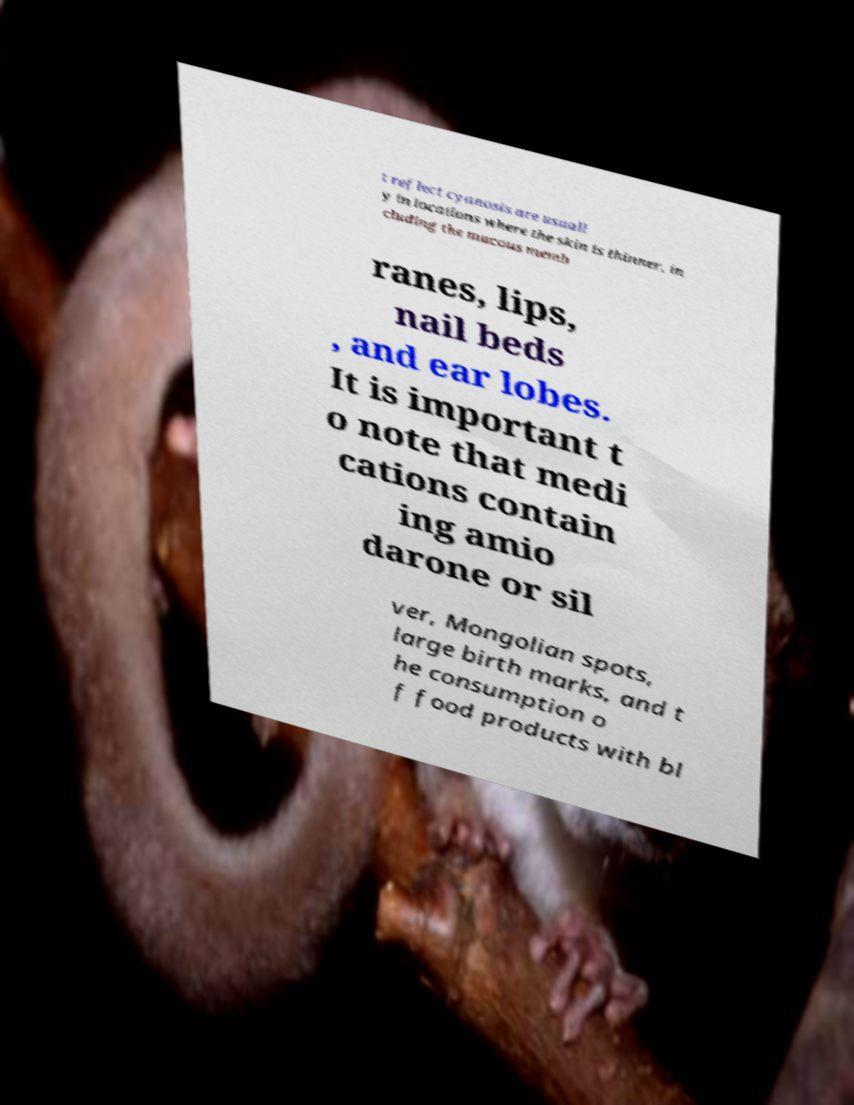Please identify and transcribe the text found in this image. t reflect cyanosis are usuall y in locations where the skin is thinner, in cluding the mucous memb ranes, lips, nail beds , and ear lobes. It is important t o note that medi cations contain ing amio darone or sil ver, Mongolian spots, large birth marks, and t he consumption o f food products with bl 